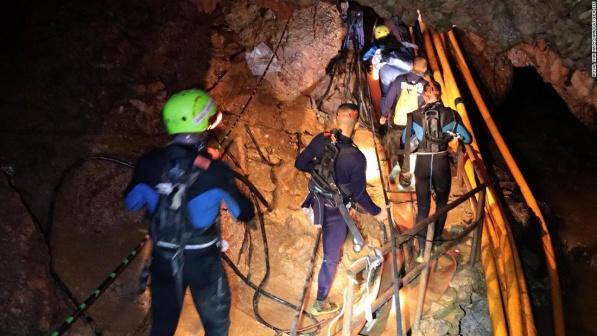Pretend you're writing a fictional scenario based on this image for a novel. Create a plot outline. Title: 'Echoes of the Abyss'

Plot Outline:

1. **Introduction:** The story opens with an intrepid group of explorers embarking on a daring expedition to map a newly discovered cave system believed to hold ancient artifacts and untapped wonders.

2. **Character Development:** We delve into the backgrounds of the five primary characters—a geologist, a biologist, an engineer, an anthropologist, and a thrill-seeker—united by their shared passion for adventure and discovery.

3. **Inciting Incident:** While exploring, they uncover a series of encrypted texts hinting at a forgotten civilization that once thrived underground, leading them deeper into the cave despite increasing challenges.

4. **Rising Action:** The group's journey is fraught with peril, including treacherous paths, dwindling supplies, and interpersonal tensions. However, they also discover breathtaking underground rivers, colossal stalactites, and hidden chambers filled with historical relics.

5. **Midpoint:** The adventurers stumble upon a mysterious artifact that triggers intense visions of the past, hinting at a powerful energy source hidden within the cave and sought after by a secret organization determined to exploit it at any cost.

6. **Conflict:** The group must fend off members of this organization who have covertly shadowed their expedition while deciphering ancient clues that lead to the energy source's location.

7. **Climax:** In a heart-pounding race against time, the adventurers evade traps, engage in a battle of wits and endurance, and ultimately confront the organization in a cavernous chamber where the energy source is revealed.

8. **Resolution:** The protagonists successfully protect the energy source, realizing its potential for both creation and destruction. They decide to seal the chamber to preserve its secrets, returning to the surface deeply changed by their journey.

9. **Conclusion:** The novel concludes with the adventurers parting ways, each carrying new insights and a sense of accomplishment, and leaving readers with a lingering curiosity about the hidden wonders that still lie beneath the earth's surface. 